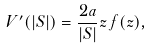<formula> <loc_0><loc_0><loc_500><loc_500>V ^ { \prime } ( | S | ) = \frac { 2 a } { | S | } z \, f ( z ) ,</formula> 